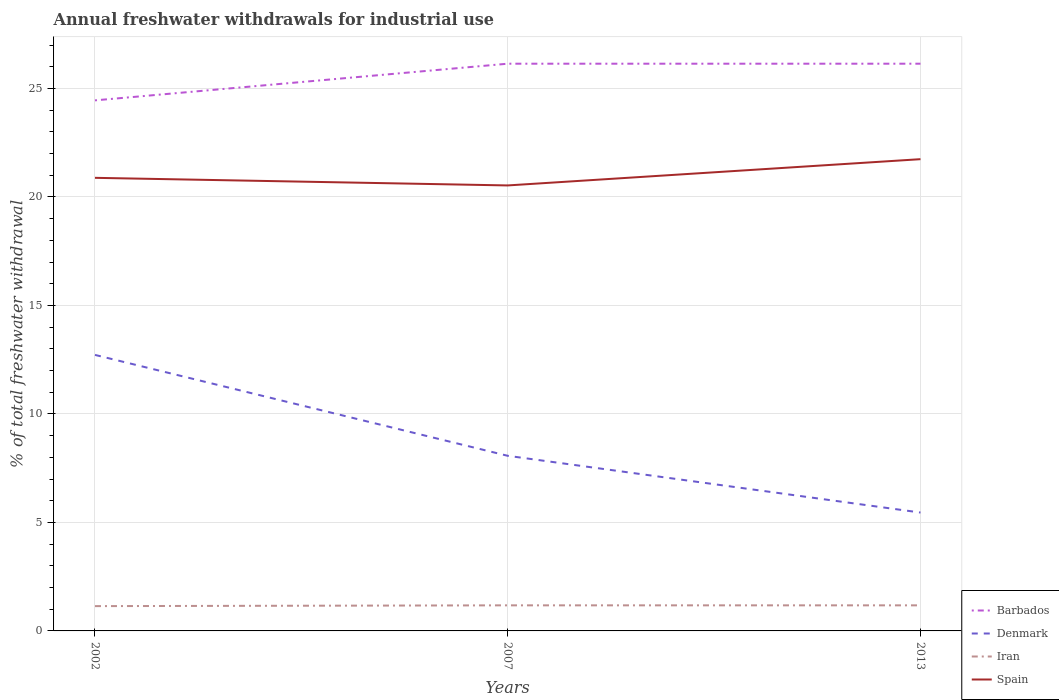How many different coloured lines are there?
Give a very brief answer. 4. Across all years, what is the maximum total annual withdrawals from freshwater in Iran?
Your answer should be very brief. 1.14. In which year was the total annual withdrawals from freshwater in Iran maximum?
Provide a succinct answer. 2002. What is the total total annual withdrawals from freshwater in Denmark in the graph?
Offer a very short reply. 4.65. What is the difference between the highest and the second highest total annual withdrawals from freshwater in Spain?
Make the answer very short. 1.21. What is the difference between the highest and the lowest total annual withdrawals from freshwater in Spain?
Keep it short and to the point. 1. How many lines are there?
Give a very brief answer. 4. What is the difference between two consecutive major ticks on the Y-axis?
Ensure brevity in your answer.  5. How many legend labels are there?
Give a very brief answer. 4. How are the legend labels stacked?
Offer a very short reply. Vertical. What is the title of the graph?
Your answer should be very brief. Annual freshwater withdrawals for industrial use. What is the label or title of the Y-axis?
Your answer should be very brief. % of total freshwater withdrawal. What is the % of total freshwater withdrawal in Barbados in 2002?
Make the answer very short. 24.45. What is the % of total freshwater withdrawal in Denmark in 2002?
Provide a short and direct response. 12.72. What is the % of total freshwater withdrawal of Iran in 2002?
Offer a terse response. 1.14. What is the % of total freshwater withdrawal in Spain in 2002?
Offer a very short reply. 20.88. What is the % of total freshwater withdrawal in Barbados in 2007?
Give a very brief answer. 26.14. What is the % of total freshwater withdrawal of Denmark in 2007?
Provide a short and direct response. 8.07. What is the % of total freshwater withdrawal of Iran in 2007?
Give a very brief answer. 1.18. What is the % of total freshwater withdrawal of Spain in 2007?
Offer a very short reply. 20.53. What is the % of total freshwater withdrawal of Barbados in 2013?
Keep it short and to the point. 26.14. What is the % of total freshwater withdrawal of Denmark in 2013?
Your answer should be compact. 5.46. What is the % of total freshwater withdrawal of Iran in 2013?
Ensure brevity in your answer.  1.18. What is the % of total freshwater withdrawal of Spain in 2013?
Offer a terse response. 21.74. Across all years, what is the maximum % of total freshwater withdrawal of Barbados?
Offer a very short reply. 26.14. Across all years, what is the maximum % of total freshwater withdrawal in Denmark?
Make the answer very short. 12.72. Across all years, what is the maximum % of total freshwater withdrawal in Iran?
Your answer should be compact. 1.18. Across all years, what is the maximum % of total freshwater withdrawal of Spain?
Offer a very short reply. 21.74. Across all years, what is the minimum % of total freshwater withdrawal in Barbados?
Your answer should be compact. 24.45. Across all years, what is the minimum % of total freshwater withdrawal in Denmark?
Your response must be concise. 5.46. Across all years, what is the minimum % of total freshwater withdrawal in Iran?
Provide a succinct answer. 1.14. Across all years, what is the minimum % of total freshwater withdrawal of Spain?
Offer a very short reply. 20.53. What is the total % of total freshwater withdrawal in Barbados in the graph?
Your answer should be compact. 76.73. What is the total % of total freshwater withdrawal of Denmark in the graph?
Keep it short and to the point. 26.25. What is the total % of total freshwater withdrawal in Iran in the graph?
Your answer should be very brief. 3.5. What is the total % of total freshwater withdrawal in Spain in the graph?
Provide a short and direct response. 63.15. What is the difference between the % of total freshwater withdrawal of Barbados in 2002 and that in 2007?
Provide a succinct answer. -1.69. What is the difference between the % of total freshwater withdrawal in Denmark in 2002 and that in 2007?
Offer a very short reply. 4.65. What is the difference between the % of total freshwater withdrawal of Iran in 2002 and that in 2007?
Provide a succinct answer. -0.04. What is the difference between the % of total freshwater withdrawal of Spain in 2002 and that in 2007?
Offer a terse response. 0.35. What is the difference between the % of total freshwater withdrawal in Barbados in 2002 and that in 2013?
Your answer should be very brief. -1.69. What is the difference between the % of total freshwater withdrawal of Denmark in 2002 and that in 2013?
Provide a short and direct response. 7.26. What is the difference between the % of total freshwater withdrawal of Iran in 2002 and that in 2013?
Give a very brief answer. -0.04. What is the difference between the % of total freshwater withdrawal of Spain in 2002 and that in 2013?
Your answer should be very brief. -0.86. What is the difference between the % of total freshwater withdrawal in Denmark in 2007 and that in 2013?
Give a very brief answer. 2.62. What is the difference between the % of total freshwater withdrawal in Iran in 2007 and that in 2013?
Ensure brevity in your answer.  0. What is the difference between the % of total freshwater withdrawal of Spain in 2007 and that in 2013?
Your answer should be compact. -1.21. What is the difference between the % of total freshwater withdrawal in Barbados in 2002 and the % of total freshwater withdrawal in Denmark in 2007?
Make the answer very short. 16.38. What is the difference between the % of total freshwater withdrawal of Barbados in 2002 and the % of total freshwater withdrawal of Iran in 2007?
Ensure brevity in your answer.  23.27. What is the difference between the % of total freshwater withdrawal of Barbados in 2002 and the % of total freshwater withdrawal of Spain in 2007?
Ensure brevity in your answer.  3.92. What is the difference between the % of total freshwater withdrawal in Denmark in 2002 and the % of total freshwater withdrawal in Iran in 2007?
Offer a terse response. 11.54. What is the difference between the % of total freshwater withdrawal of Denmark in 2002 and the % of total freshwater withdrawal of Spain in 2007?
Your response must be concise. -7.81. What is the difference between the % of total freshwater withdrawal in Iran in 2002 and the % of total freshwater withdrawal in Spain in 2007?
Your answer should be compact. -19.39. What is the difference between the % of total freshwater withdrawal of Barbados in 2002 and the % of total freshwater withdrawal of Denmark in 2013?
Keep it short and to the point. 19. What is the difference between the % of total freshwater withdrawal of Barbados in 2002 and the % of total freshwater withdrawal of Iran in 2013?
Offer a very short reply. 23.27. What is the difference between the % of total freshwater withdrawal in Barbados in 2002 and the % of total freshwater withdrawal in Spain in 2013?
Offer a very short reply. 2.71. What is the difference between the % of total freshwater withdrawal of Denmark in 2002 and the % of total freshwater withdrawal of Iran in 2013?
Provide a short and direct response. 11.54. What is the difference between the % of total freshwater withdrawal in Denmark in 2002 and the % of total freshwater withdrawal in Spain in 2013?
Give a very brief answer. -9.02. What is the difference between the % of total freshwater withdrawal in Iran in 2002 and the % of total freshwater withdrawal in Spain in 2013?
Provide a short and direct response. -20.6. What is the difference between the % of total freshwater withdrawal of Barbados in 2007 and the % of total freshwater withdrawal of Denmark in 2013?
Give a very brief answer. 20.68. What is the difference between the % of total freshwater withdrawal in Barbados in 2007 and the % of total freshwater withdrawal in Iran in 2013?
Your response must be concise. 24.96. What is the difference between the % of total freshwater withdrawal of Denmark in 2007 and the % of total freshwater withdrawal of Iran in 2013?
Ensure brevity in your answer.  6.89. What is the difference between the % of total freshwater withdrawal in Denmark in 2007 and the % of total freshwater withdrawal in Spain in 2013?
Your answer should be compact. -13.67. What is the difference between the % of total freshwater withdrawal in Iran in 2007 and the % of total freshwater withdrawal in Spain in 2013?
Offer a very short reply. -20.56. What is the average % of total freshwater withdrawal of Barbados per year?
Offer a terse response. 25.58. What is the average % of total freshwater withdrawal of Denmark per year?
Provide a short and direct response. 8.75. What is the average % of total freshwater withdrawal in Iran per year?
Keep it short and to the point. 1.17. What is the average % of total freshwater withdrawal in Spain per year?
Provide a succinct answer. 21.05. In the year 2002, what is the difference between the % of total freshwater withdrawal of Barbados and % of total freshwater withdrawal of Denmark?
Your answer should be compact. 11.73. In the year 2002, what is the difference between the % of total freshwater withdrawal of Barbados and % of total freshwater withdrawal of Iran?
Offer a terse response. 23.31. In the year 2002, what is the difference between the % of total freshwater withdrawal in Barbados and % of total freshwater withdrawal in Spain?
Your response must be concise. 3.57. In the year 2002, what is the difference between the % of total freshwater withdrawal of Denmark and % of total freshwater withdrawal of Iran?
Your answer should be very brief. 11.58. In the year 2002, what is the difference between the % of total freshwater withdrawal of Denmark and % of total freshwater withdrawal of Spain?
Ensure brevity in your answer.  -8.16. In the year 2002, what is the difference between the % of total freshwater withdrawal in Iran and % of total freshwater withdrawal in Spain?
Provide a short and direct response. -19.74. In the year 2007, what is the difference between the % of total freshwater withdrawal in Barbados and % of total freshwater withdrawal in Denmark?
Offer a terse response. 18.07. In the year 2007, what is the difference between the % of total freshwater withdrawal in Barbados and % of total freshwater withdrawal in Iran?
Offer a very short reply. 24.96. In the year 2007, what is the difference between the % of total freshwater withdrawal of Barbados and % of total freshwater withdrawal of Spain?
Your response must be concise. 5.61. In the year 2007, what is the difference between the % of total freshwater withdrawal in Denmark and % of total freshwater withdrawal in Iran?
Keep it short and to the point. 6.89. In the year 2007, what is the difference between the % of total freshwater withdrawal in Denmark and % of total freshwater withdrawal in Spain?
Give a very brief answer. -12.46. In the year 2007, what is the difference between the % of total freshwater withdrawal in Iran and % of total freshwater withdrawal in Spain?
Ensure brevity in your answer.  -19.35. In the year 2013, what is the difference between the % of total freshwater withdrawal of Barbados and % of total freshwater withdrawal of Denmark?
Offer a terse response. 20.68. In the year 2013, what is the difference between the % of total freshwater withdrawal in Barbados and % of total freshwater withdrawal in Iran?
Keep it short and to the point. 24.96. In the year 2013, what is the difference between the % of total freshwater withdrawal of Denmark and % of total freshwater withdrawal of Iran?
Keep it short and to the point. 4.28. In the year 2013, what is the difference between the % of total freshwater withdrawal in Denmark and % of total freshwater withdrawal in Spain?
Provide a succinct answer. -16.29. In the year 2013, what is the difference between the % of total freshwater withdrawal of Iran and % of total freshwater withdrawal of Spain?
Your answer should be very brief. -20.56. What is the ratio of the % of total freshwater withdrawal in Barbados in 2002 to that in 2007?
Give a very brief answer. 0.94. What is the ratio of the % of total freshwater withdrawal of Denmark in 2002 to that in 2007?
Offer a very short reply. 1.58. What is the ratio of the % of total freshwater withdrawal of Iran in 2002 to that in 2007?
Provide a succinct answer. 0.97. What is the ratio of the % of total freshwater withdrawal in Spain in 2002 to that in 2007?
Your answer should be very brief. 1.02. What is the ratio of the % of total freshwater withdrawal of Barbados in 2002 to that in 2013?
Your answer should be compact. 0.94. What is the ratio of the % of total freshwater withdrawal of Denmark in 2002 to that in 2013?
Your answer should be very brief. 2.33. What is the ratio of the % of total freshwater withdrawal of Iran in 2002 to that in 2013?
Ensure brevity in your answer.  0.97. What is the ratio of the % of total freshwater withdrawal in Spain in 2002 to that in 2013?
Your answer should be very brief. 0.96. What is the ratio of the % of total freshwater withdrawal in Denmark in 2007 to that in 2013?
Give a very brief answer. 1.48. What is the ratio of the % of total freshwater withdrawal in Spain in 2007 to that in 2013?
Your answer should be compact. 0.94. What is the difference between the highest and the second highest % of total freshwater withdrawal of Barbados?
Make the answer very short. 0. What is the difference between the highest and the second highest % of total freshwater withdrawal in Denmark?
Your answer should be compact. 4.65. What is the difference between the highest and the second highest % of total freshwater withdrawal of Spain?
Offer a very short reply. 0.86. What is the difference between the highest and the lowest % of total freshwater withdrawal of Barbados?
Give a very brief answer. 1.69. What is the difference between the highest and the lowest % of total freshwater withdrawal of Denmark?
Make the answer very short. 7.26. What is the difference between the highest and the lowest % of total freshwater withdrawal in Iran?
Give a very brief answer. 0.04. What is the difference between the highest and the lowest % of total freshwater withdrawal of Spain?
Offer a very short reply. 1.21. 